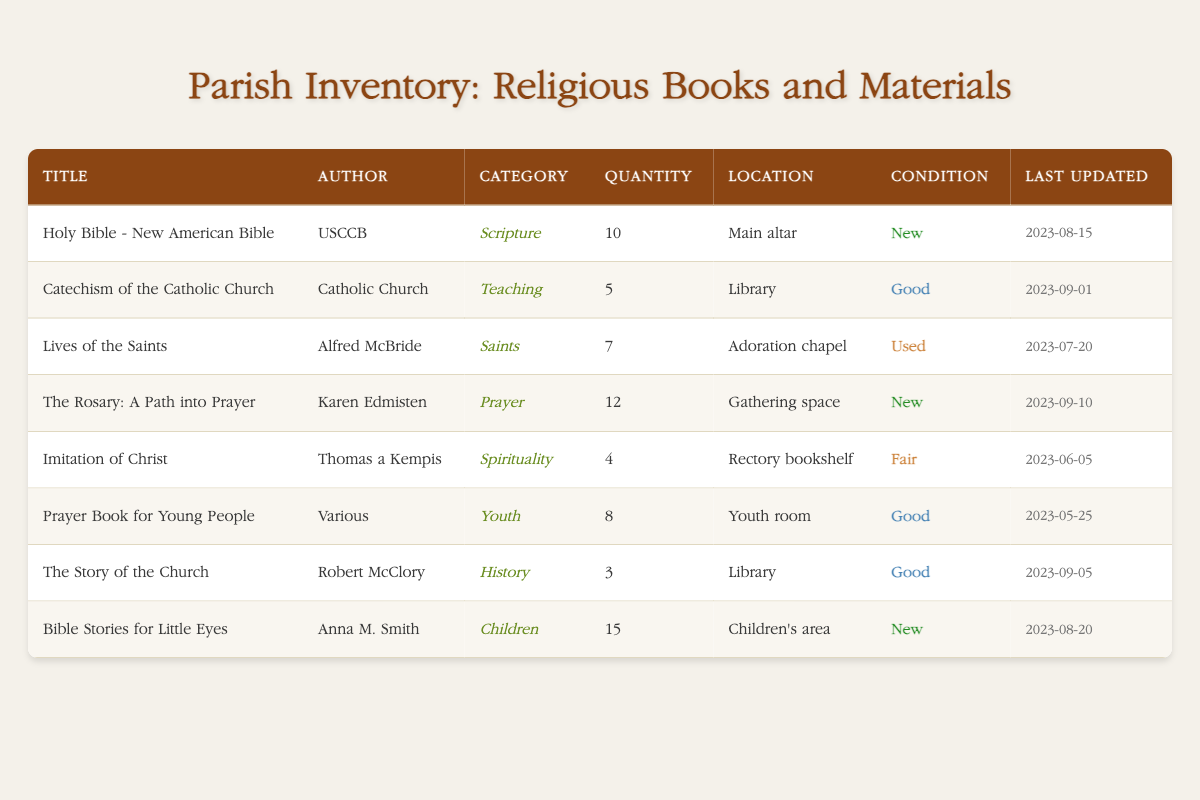What is the location of the "Lives of the Saints"? The table indicates that "Lives of the Saints" is located in the Adoration chapel.
Answer: Adoration chapel How many copies of the "Her Book: A Path into Prayer" are there? Referring to the table, there are 12 copies of "The Rosary: A Path into Prayer."
Answer: 12 Which book has the least quantity available? Looking at the quantity column, the book "The Story of the Church" has 3 copies available, which is the lowest compared to others.
Answer: 3 Is the "Catechism of the Catholic Church" in good condition? The table shows that the condition of the "Catechism of the Catholic Church" is marked as Good.
Answer: Yes What is the total number of new books listed in the inventory? By counting the entries that have "New" indicated in the condition column, the total is 4 ("Holy Bible," "The Rosary," "Bible Stories for Little Eyes"). Thus, the sum is 4.
Answer: 4 Which author has the most books available in the inventory? Comparing the books by quantity, "Anna M. Smith" has the most with "Bible Stories for Little Eyes" having 15 copies, more than any other author.
Answer: Anna M. Smith What is the average quantity of books in "Good" condition? There are 4 books with "Good" condition (Catechism, Prayer Book for Young People, The Story of the Church) with quantities 5, 8, and 3 respectively. The sum is 16, and the average is 16/4 = 4.
Answer: 4 How many different categories of books are there in total? The categories present are Scripture, Teaching, Saints, Prayer, Spirituality, Youth, History, and Children. This adds up to 8 distinct categories in total.
Answer: 8 Was "Imitation of Christ" last updated before August 2023? The "Imitation of Christ" was last updated on June 5, 2023, which is indeed before August 2023.
Answer: Yes 